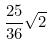Convert formula to latex. <formula><loc_0><loc_0><loc_500><loc_500>\frac { 2 5 } { 3 6 } \sqrt { 2 }</formula> 